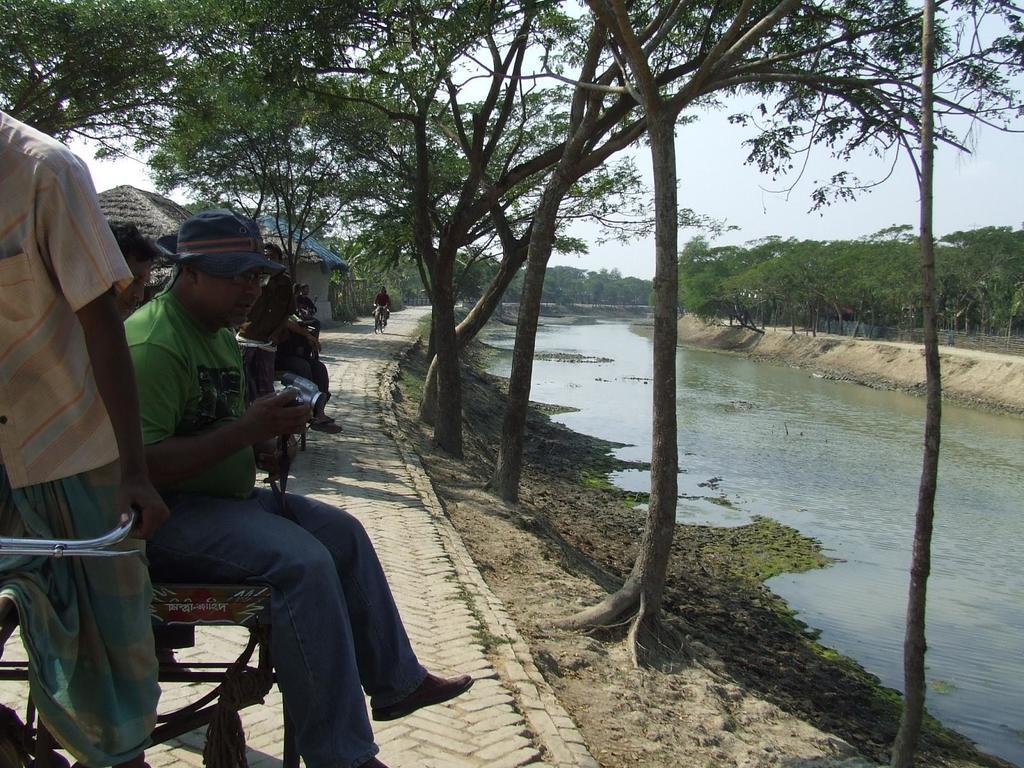Please provide a concise description of this image. In this image I can see number of trees and a small river. In the background I can see few houses. Here I can see a road where a person cycling his cycle, in the back a man is sitting with the camera in his hand and he is wearing a cap. 